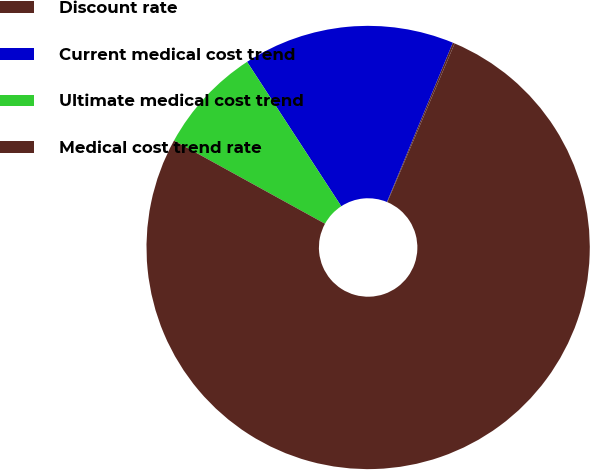<chart> <loc_0><loc_0><loc_500><loc_500><pie_chart><fcel>Discount rate<fcel>Current medical cost trend<fcel>Ultimate medical cost trend<fcel>Medical cost trend rate<nl><fcel>0.14%<fcel>15.44%<fcel>7.79%<fcel>76.63%<nl></chart> 